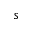<formula> <loc_0><loc_0><loc_500><loc_500>s</formula> 